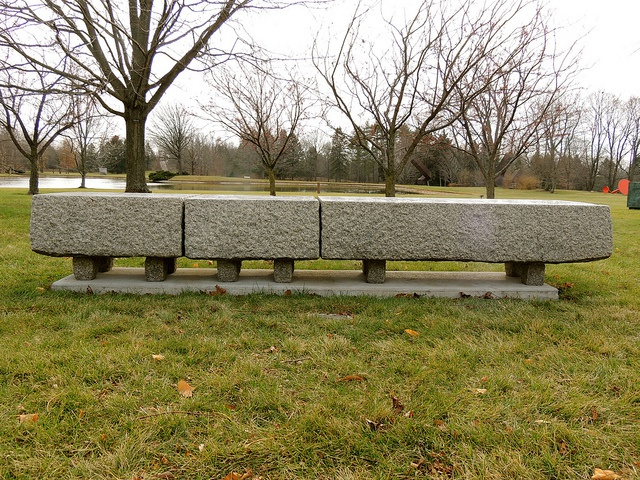Describe the objects in this image and their specific colors. I can see a bench in white, gray, and darkgray tones in this image. 